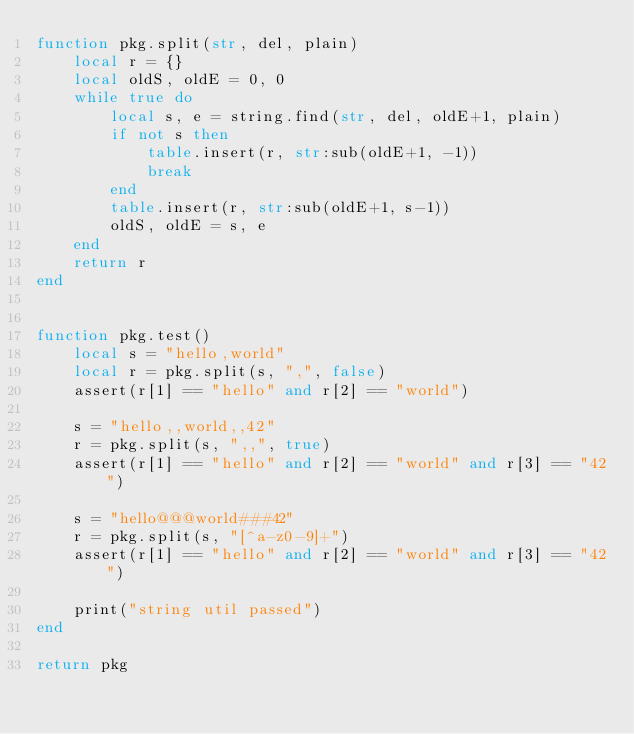Convert code to text. <code><loc_0><loc_0><loc_500><loc_500><_Lua_>function pkg.split(str, del, plain)
    local r = {}
    local oldS, oldE = 0, 0
    while true do
        local s, e = string.find(str, del, oldE+1, plain)
        if not s then
            table.insert(r, str:sub(oldE+1, -1))
            break
        end
        table.insert(r, str:sub(oldE+1, s-1))
        oldS, oldE = s, e
    end
    return r
end


function pkg.test()
    local s = "hello,world"
    local r = pkg.split(s, ",", false)
    assert(r[1] == "hello" and r[2] == "world")

    s = "hello,,world,,42"
    r = pkg.split(s, ",,", true)
    assert(r[1] == "hello" and r[2] == "world" and r[3] == "42")

    s = "hello@@@world###42"
    r = pkg.split(s, "[^a-z0-9]+")
    assert(r[1] == "hello" and r[2] == "world" and r[3] == "42")

    print("string util passed")
end

return pkg

</code> 